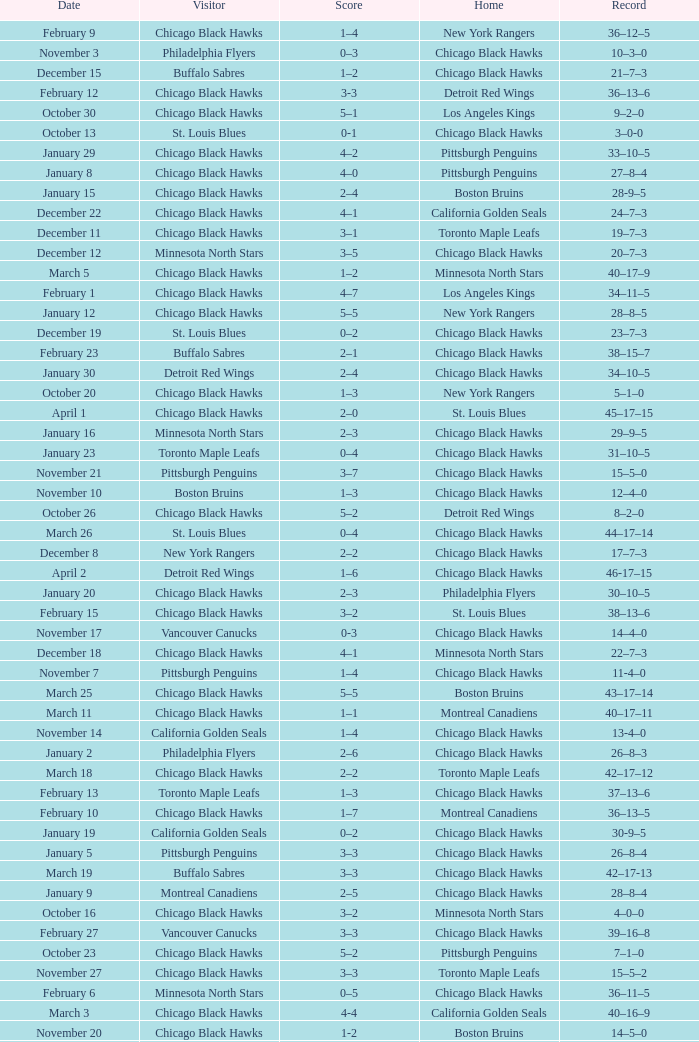What is the Score of the Chicago Black Hawks Home game with the Visiting Vancouver Canucks on November 17? 0-3. 